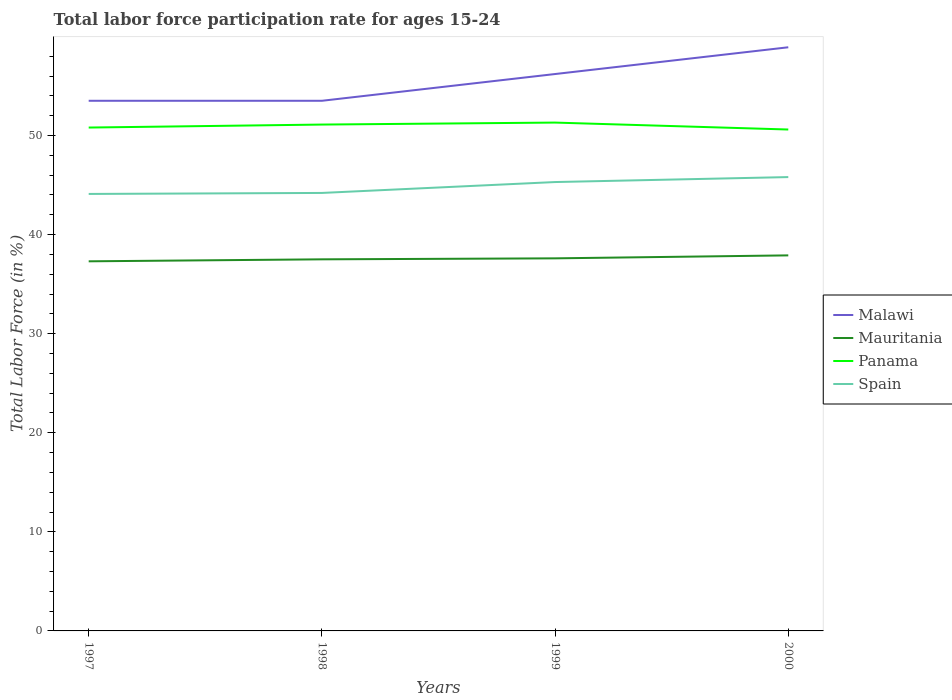How many different coloured lines are there?
Your response must be concise. 4. Across all years, what is the maximum labor force participation rate in Mauritania?
Provide a succinct answer. 37.3. In which year was the labor force participation rate in Panama maximum?
Keep it short and to the point. 2000. What is the total labor force participation rate in Panama in the graph?
Provide a succinct answer. 0.7. What is the difference between the highest and the second highest labor force participation rate in Malawi?
Your answer should be compact. 5.4. What is the difference between the highest and the lowest labor force participation rate in Mauritania?
Provide a succinct answer. 2. Is the labor force participation rate in Spain strictly greater than the labor force participation rate in Malawi over the years?
Ensure brevity in your answer.  Yes. How many lines are there?
Your answer should be compact. 4. What is the difference between two consecutive major ticks on the Y-axis?
Provide a short and direct response. 10. Where does the legend appear in the graph?
Offer a terse response. Center right. What is the title of the graph?
Your answer should be very brief. Total labor force participation rate for ages 15-24. What is the label or title of the X-axis?
Ensure brevity in your answer.  Years. What is the Total Labor Force (in %) of Malawi in 1997?
Ensure brevity in your answer.  53.5. What is the Total Labor Force (in %) in Mauritania in 1997?
Make the answer very short. 37.3. What is the Total Labor Force (in %) of Panama in 1997?
Your response must be concise. 50.8. What is the Total Labor Force (in %) of Spain in 1997?
Offer a terse response. 44.1. What is the Total Labor Force (in %) in Malawi in 1998?
Your answer should be very brief. 53.5. What is the Total Labor Force (in %) of Mauritania in 1998?
Ensure brevity in your answer.  37.5. What is the Total Labor Force (in %) of Panama in 1998?
Ensure brevity in your answer.  51.1. What is the Total Labor Force (in %) in Spain in 1998?
Your answer should be very brief. 44.2. What is the Total Labor Force (in %) of Malawi in 1999?
Offer a terse response. 56.2. What is the Total Labor Force (in %) of Mauritania in 1999?
Provide a succinct answer. 37.6. What is the Total Labor Force (in %) in Panama in 1999?
Give a very brief answer. 51.3. What is the Total Labor Force (in %) of Spain in 1999?
Your answer should be compact. 45.3. What is the Total Labor Force (in %) of Malawi in 2000?
Ensure brevity in your answer.  58.9. What is the Total Labor Force (in %) in Mauritania in 2000?
Offer a very short reply. 37.9. What is the Total Labor Force (in %) in Panama in 2000?
Your answer should be compact. 50.6. What is the Total Labor Force (in %) of Spain in 2000?
Keep it short and to the point. 45.8. Across all years, what is the maximum Total Labor Force (in %) of Malawi?
Ensure brevity in your answer.  58.9. Across all years, what is the maximum Total Labor Force (in %) of Mauritania?
Ensure brevity in your answer.  37.9. Across all years, what is the maximum Total Labor Force (in %) of Panama?
Provide a succinct answer. 51.3. Across all years, what is the maximum Total Labor Force (in %) of Spain?
Keep it short and to the point. 45.8. Across all years, what is the minimum Total Labor Force (in %) of Malawi?
Provide a succinct answer. 53.5. Across all years, what is the minimum Total Labor Force (in %) in Mauritania?
Provide a succinct answer. 37.3. Across all years, what is the minimum Total Labor Force (in %) of Panama?
Provide a short and direct response. 50.6. Across all years, what is the minimum Total Labor Force (in %) of Spain?
Ensure brevity in your answer.  44.1. What is the total Total Labor Force (in %) in Malawi in the graph?
Keep it short and to the point. 222.1. What is the total Total Labor Force (in %) of Mauritania in the graph?
Provide a short and direct response. 150.3. What is the total Total Labor Force (in %) of Panama in the graph?
Ensure brevity in your answer.  203.8. What is the total Total Labor Force (in %) of Spain in the graph?
Ensure brevity in your answer.  179.4. What is the difference between the Total Labor Force (in %) in Mauritania in 1997 and that in 1998?
Ensure brevity in your answer.  -0.2. What is the difference between the Total Labor Force (in %) in Panama in 1997 and that in 1998?
Offer a very short reply. -0.3. What is the difference between the Total Labor Force (in %) of Malawi in 1997 and that in 1999?
Provide a succinct answer. -2.7. What is the difference between the Total Labor Force (in %) of Mauritania in 1997 and that in 1999?
Keep it short and to the point. -0.3. What is the difference between the Total Labor Force (in %) in Spain in 1997 and that in 1999?
Provide a short and direct response. -1.2. What is the difference between the Total Labor Force (in %) in Malawi in 1997 and that in 2000?
Ensure brevity in your answer.  -5.4. What is the difference between the Total Labor Force (in %) in Mauritania in 1997 and that in 2000?
Offer a very short reply. -0.6. What is the difference between the Total Labor Force (in %) in Malawi in 1998 and that in 1999?
Offer a terse response. -2.7. What is the difference between the Total Labor Force (in %) in Mauritania in 1998 and that in 1999?
Ensure brevity in your answer.  -0.1. What is the difference between the Total Labor Force (in %) of Spain in 1998 and that in 1999?
Offer a very short reply. -1.1. What is the difference between the Total Labor Force (in %) in Panama in 1998 and that in 2000?
Keep it short and to the point. 0.5. What is the difference between the Total Labor Force (in %) of Spain in 1998 and that in 2000?
Your answer should be compact. -1.6. What is the difference between the Total Labor Force (in %) in Malawi in 1999 and that in 2000?
Your response must be concise. -2.7. What is the difference between the Total Labor Force (in %) in Mauritania in 1999 and that in 2000?
Provide a short and direct response. -0.3. What is the difference between the Total Labor Force (in %) of Spain in 1999 and that in 2000?
Offer a very short reply. -0.5. What is the difference between the Total Labor Force (in %) of Malawi in 1997 and the Total Labor Force (in %) of Mauritania in 1998?
Ensure brevity in your answer.  16. What is the difference between the Total Labor Force (in %) in Malawi in 1997 and the Total Labor Force (in %) in Spain in 1998?
Offer a very short reply. 9.3. What is the difference between the Total Labor Force (in %) of Mauritania in 1997 and the Total Labor Force (in %) of Spain in 1998?
Provide a short and direct response. -6.9. What is the difference between the Total Labor Force (in %) of Malawi in 1997 and the Total Labor Force (in %) of Spain in 1999?
Your response must be concise. 8.2. What is the difference between the Total Labor Force (in %) of Panama in 1997 and the Total Labor Force (in %) of Spain in 1999?
Give a very brief answer. 5.5. What is the difference between the Total Labor Force (in %) in Mauritania in 1997 and the Total Labor Force (in %) in Spain in 2000?
Offer a very short reply. -8.5. What is the difference between the Total Labor Force (in %) of Malawi in 1998 and the Total Labor Force (in %) of Mauritania in 1999?
Ensure brevity in your answer.  15.9. What is the difference between the Total Labor Force (in %) in Malawi in 1998 and the Total Labor Force (in %) in Spain in 1999?
Provide a succinct answer. 8.2. What is the difference between the Total Labor Force (in %) of Mauritania in 1998 and the Total Labor Force (in %) of Panama in 1999?
Keep it short and to the point. -13.8. What is the difference between the Total Labor Force (in %) in Mauritania in 1998 and the Total Labor Force (in %) in Spain in 1999?
Offer a very short reply. -7.8. What is the difference between the Total Labor Force (in %) of Panama in 1998 and the Total Labor Force (in %) of Spain in 1999?
Offer a terse response. 5.8. What is the difference between the Total Labor Force (in %) of Malawi in 1998 and the Total Labor Force (in %) of Panama in 2000?
Keep it short and to the point. 2.9. What is the difference between the Total Labor Force (in %) in Malawi in 1998 and the Total Labor Force (in %) in Spain in 2000?
Provide a succinct answer. 7.7. What is the difference between the Total Labor Force (in %) in Mauritania in 1998 and the Total Labor Force (in %) in Panama in 2000?
Your answer should be compact. -13.1. What is the difference between the Total Labor Force (in %) in Malawi in 1999 and the Total Labor Force (in %) in Mauritania in 2000?
Make the answer very short. 18.3. What is the difference between the Total Labor Force (in %) of Malawi in 1999 and the Total Labor Force (in %) of Panama in 2000?
Offer a terse response. 5.6. What is the difference between the Total Labor Force (in %) of Mauritania in 1999 and the Total Labor Force (in %) of Panama in 2000?
Ensure brevity in your answer.  -13. What is the difference between the Total Labor Force (in %) of Mauritania in 1999 and the Total Labor Force (in %) of Spain in 2000?
Keep it short and to the point. -8.2. What is the difference between the Total Labor Force (in %) of Panama in 1999 and the Total Labor Force (in %) of Spain in 2000?
Offer a very short reply. 5.5. What is the average Total Labor Force (in %) of Malawi per year?
Offer a terse response. 55.52. What is the average Total Labor Force (in %) of Mauritania per year?
Offer a terse response. 37.58. What is the average Total Labor Force (in %) in Panama per year?
Ensure brevity in your answer.  50.95. What is the average Total Labor Force (in %) of Spain per year?
Make the answer very short. 44.85. In the year 1997, what is the difference between the Total Labor Force (in %) in Malawi and Total Labor Force (in %) in Mauritania?
Your answer should be very brief. 16.2. In the year 1997, what is the difference between the Total Labor Force (in %) in Mauritania and Total Labor Force (in %) in Spain?
Provide a succinct answer. -6.8. In the year 1997, what is the difference between the Total Labor Force (in %) in Panama and Total Labor Force (in %) in Spain?
Offer a terse response. 6.7. In the year 1998, what is the difference between the Total Labor Force (in %) in Malawi and Total Labor Force (in %) in Mauritania?
Make the answer very short. 16. In the year 1998, what is the difference between the Total Labor Force (in %) of Malawi and Total Labor Force (in %) of Spain?
Ensure brevity in your answer.  9.3. In the year 1998, what is the difference between the Total Labor Force (in %) of Mauritania and Total Labor Force (in %) of Panama?
Your answer should be compact. -13.6. In the year 1998, what is the difference between the Total Labor Force (in %) of Panama and Total Labor Force (in %) of Spain?
Your response must be concise. 6.9. In the year 1999, what is the difference between the Total Labor Force (in %) in Malawi and Total Labor Force (in %) in Mauritania?
Offer a very short reply. 18.6. In the year 1999, what is the difference between the Total Labor Force (in %) in Malawi and Total Labor Force (in %) in Panama?
Your answer should be very brief. 4.9. In the year 1999, what is the difference between the Total Labor Force (in %) in Mauritania and Total Labor Force (in %) in Panama?
Your answer should be compact. -13.7. In the year 2000, what is the difference between the Total Labor Force (in %) of Malawi and Total Labor Force (in %) of Mauritania?
Keep it short and to the point. 21. In the year 2000, what is the difference between the Total Labor Force (in %) in Malawi and Total Labor Force (in %) in Panama?
Make the answer very short. 8.3. In the year 2000, what is the difference between the Total Labor Force (in %) in Mauritania and Total Labor Force (in %) in Panama?
Keep it short and to the point. -12.7. What is the ratio of the Total Labor Force (in %) in Mauritania in 1997 to that in 1998?
Your answer should be very brief. 0.99. What is the ratio of the Total Labor Force (in %) of Panama in 1997 to that in 1998?
Keep it short and to the point. 0.99. What is the ratio of the Total Labor Force (in %) in Spain in 1997 to that in 1998?
Offer a terse response. 1. What is the ratio of the Total Labor Force (in %) of Malawi in 1997 to that in 1999?
Offer a very short reply. 0.95. What is the ratio of the Total Labor Force (in %) in Panama in 1997 to that in 1999?
Give a very brief answer. 0.99. What is the ratio of the Total Labor Force (in %) of Spain in 1997 to that in 1999?
Provide a short and direct response. 0.97. What is the ratio of the Total Labor Force (in %) in Malawi in 1997 to that in 2000?
Offer a very short reply. 0.91. What is the ratio of the Total Labor Force (in %) of Mauritania in 1997 to that in 2000?
Make the answer very short. 0.98. What is the ratio of the Total Labor Force (in %) in Panama in 1997 to that in 2000?
Offer a very short reply. 1. What is the ratio of the Total Labor Force (in %) in Spain in 1997 to that in 2000?
Make the answer very short. 0.96. What is the ratio of the Total Labor Force (in %) of Mauritania in 1998 to that in 1999?
Provide a short and direct response. 1. What is the ratio of the Total Labor Force (in %) of Spain in 1998 to that in 1999?
Your response must be concise. 0.98. What is the ratio of the Total Labor Force (in %) in Malawi in 1998 to that in 2000?
Your answer should be very brief. 0.91. What is the ratio of the Total Labor Force (in %) in Mauritania in 1998 to that in 2000?
Provide a succinct answer. 0.99. What is the ratio of the Total Labor Force (in %) in Panama in 1998 to that in 2000?
Give a very brief answer. 1.01. What is the ratio of the Total Labor Force (in %) in Spain in 1998 to that in 2000?
Give a very brief answer. 0.97. What is the ratio of the Total Labor Force (in %) of Malawi in 1999 to that in 2000?
Provide a short and direct response. 0.95. What is the ratio of the Total Labor Force (in %) of Mauritania in 1999 to that in 2000?
Keep it short and to the point. 0.99. What is the ratio of the Total Labor Force (in %) in Panama in 1999 to that in 2000?
Ensure brevity in your answer.  1.01. What is the ratio of the Total Labor Force (in %) of Spain in 1999 to that in 2000?
Give a very brief answer. 0.99. What is the difference between the highest and the second highest Total Labor Force (in %) in Malawi?
Offer a very short reply. 2.7. What is the difference between the highest and the lowest Total Labor Force (in %) in Malawi?
Ensure brevity in your answer.  5.4. What is the difference between the highest and the lowest Total Labor Force (in %) in Panama?
Provide a short and direct response. 0.7. 